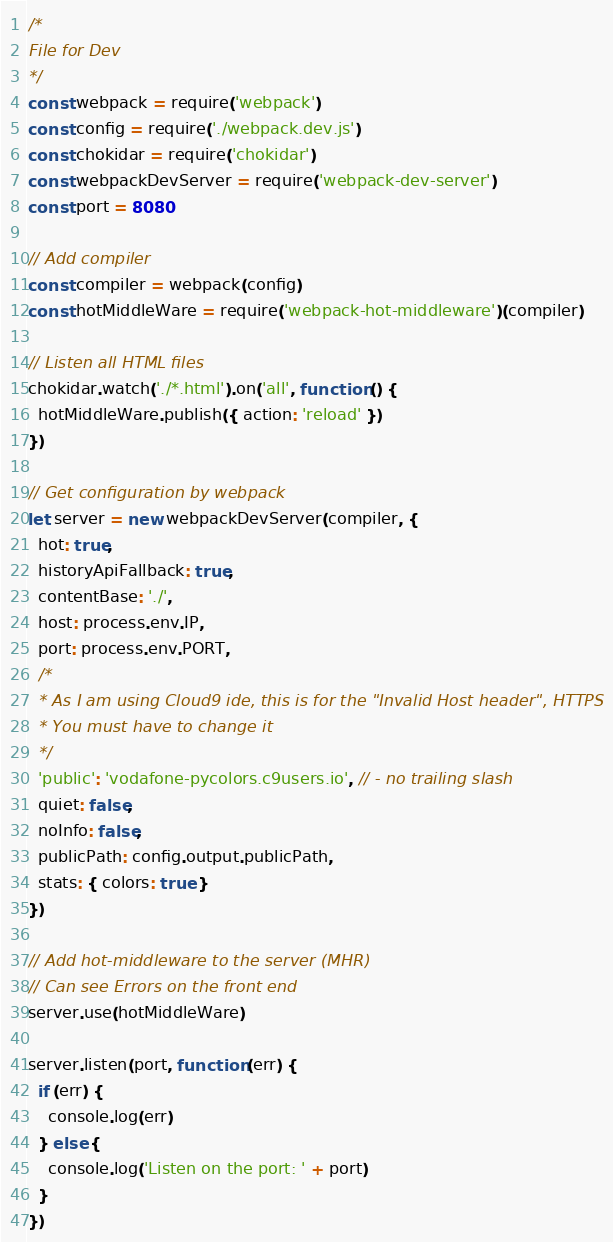Convert code to text. <code><loc_0><loc_0><loc_500><loc_500><_JavaScript_>/*
File for Dev
*/
const webpack = require('webpack')
const config = require('./webpack.dev.js')
const chokidar = require('chokidar')
const webpackDevServer = require('webpack-dev-server')
const port = 8080

// Add compiler
const compiler = webpack(config)
const hotMiddleWare = require('webpack-hot-middleware')(compiler)

// Listen all HTML files
chokidar.watch('./*.html').on('all', function () {
  hotMiddleWare.publish({ action: 'reload' })
})

// Get configuration by webpack
let server = new webpackDevServer(compiler, {
  hot: true,
  historyApiFallback: true,
  contentBase: './',
  host: process.env.IP,
  port: process.env.PORT,
  /*
  * As I am using Cloud9 ide, this is for the "Invalid Host header", HTTPS
  * You must have to change it
  */
  'public': 'vodafone-pycolors.c9users.io', // - no trailing slash
  quiet: false,
  noInfo: false,
  publicPath: config.output.publicPath,
  stats: { colors: true }
})

// Add hot-middleware to the server (MHR)
// Can see Errors on the front end
server.use(hotMiddleWare)

server.listen(port, function (err) {
  if (err) {
    console.log(err)
  } else {
    console.log('Listen on the port: ' + port)
  }
})
</code> 